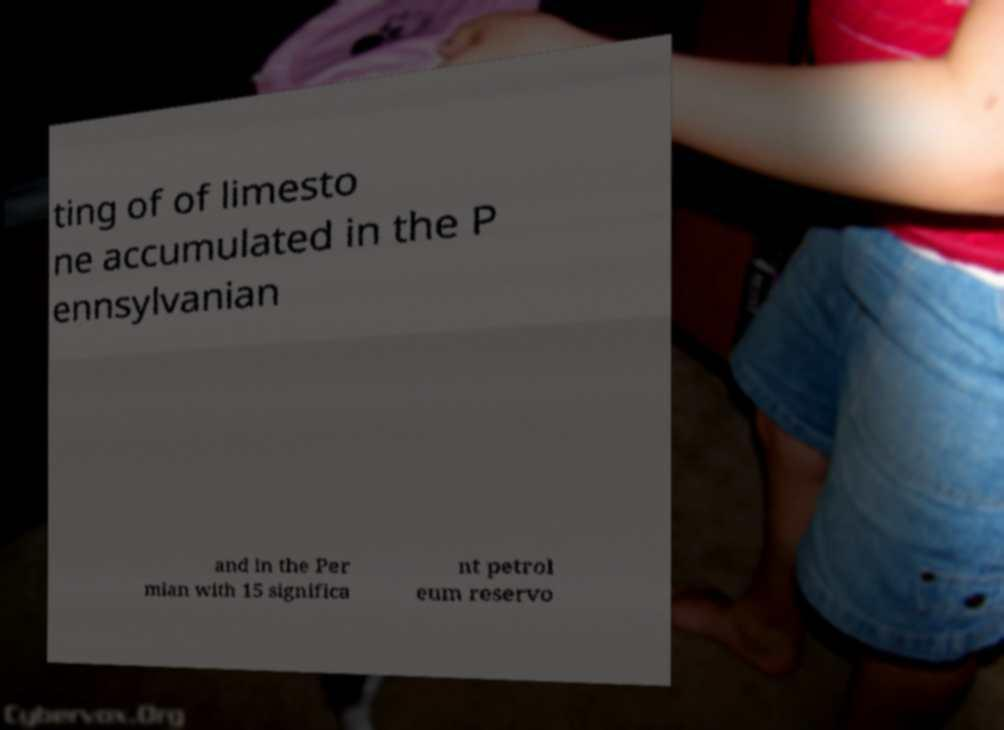Can you read and provide the text displayed in the image?This photo seems to have some interesting text. Can you extract and type it out for me? ting of of limesto ne accumulated in the P ennsylvanian and in the Per mian with 15 significa nt petrol eum reservo 